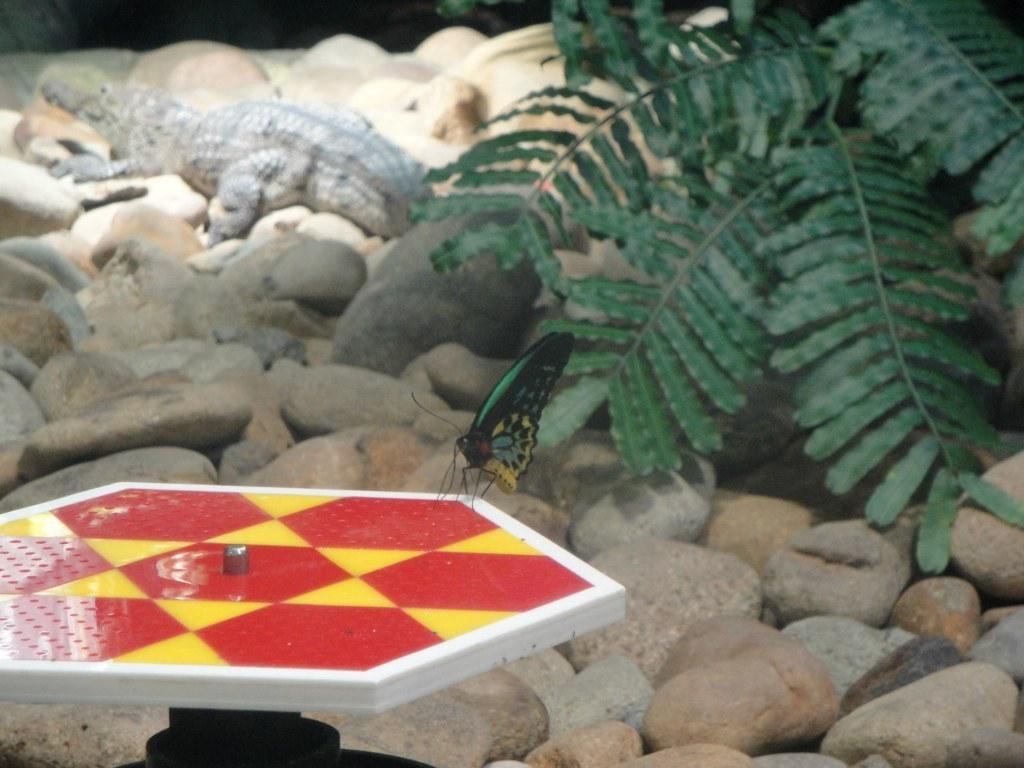What is on the table in the image? There is a butterfly on a table in the image. What can be seen on the right side of the image? There is a plant on the right side of the image. What type of animal is present in the image? There is a crocodile in the image. What type of objects are present on the ground in the image? There are stones in the image. What type of needle is being used to sew the veil in the image? There is no needle or veil present in the image. 